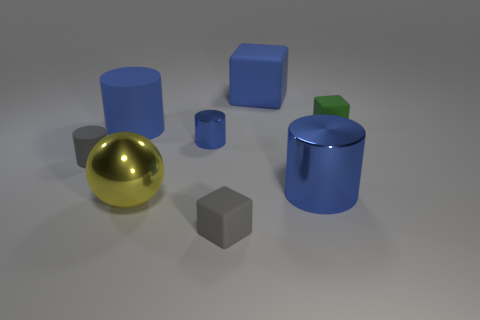There is a thing that is on the right side of the blue block and in front of the green thing; what is it made of?
Offer a terse response. Metal. What color is the big shiny cylinder?
Provide a succinct answer. Blue. How many other objects are there of the same shape as the green matte object?
Ensure brevity in your answer.  2. Is the number of tiny green matte objects that are left of the yellow shiny sphere the same as the number of tiny blue cylinders that are in front of the small blue metallic object?
Your answer should be compact. Yes. What material is the big block?
Give a very brief answer. Rubber. There is a small object that is in front of the large metal cylinder; what is it made of?
Provide a succinct answer. Rubber. Is there any other thing that has the same material as the small green thing?
Make the answer very short. Yes. Is the number of large blue cylinders that are to the left of the big yellow metallic sphere greater than the number of rubber things?
Keep it short and to the point. No. There is a small cube to the left of the blue rubber thing on the right side of the yellow metallic object; are there any tiny gray matte cylinders that are right of it?
Keep it short and to the point. No. Are there any yellow metal things behind the small blue cylinder?
Provide a short and direct response. No. 